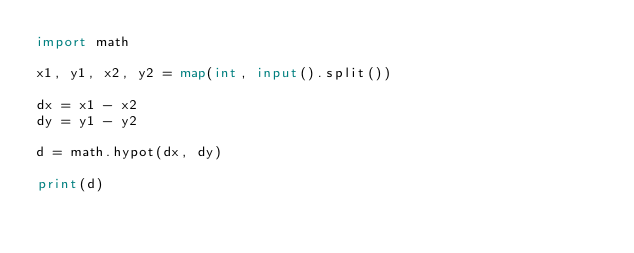<code> <loc_0><loc_0><loc_500><loc_500><_Python_>import math

x1, y1, x2, y2 = map(int, input().split())

dx = x1 - x2
dy = y1 - y2

d = math.hypot(dx, dy)

print(d)</code> 